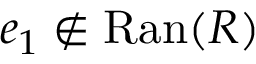<formula> <loc_0><loc_0><loc_500><loc_500>e _ { 1 } \not \in R a n ( R )</formula> 